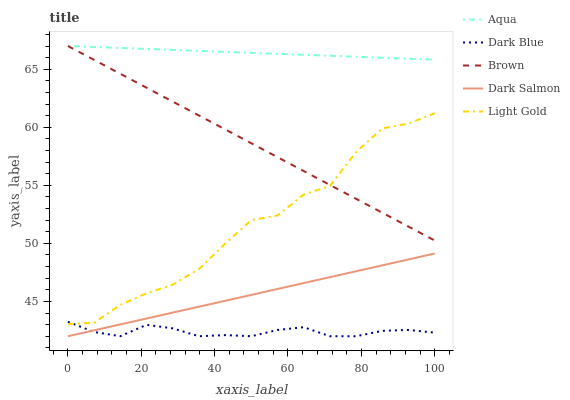Does Dark Blue have the minimum area under the curve?
Answer yes or no. Yes. Does Aqua have the maximum area under the curve?
Answer yes or no. Yes. Does Light Gold have the minimum area under the curve?
Answer yes or no. No. Does Light Gold have the maximum area under the curve?
Answer yes or no. No. Is Brown the smoothest?
Answer yes or no. Yes. Is Light Gold the roughest?
Answer yes or no. Yes. Is Aqua the smoothest?
Answer yes or no. No. Is Aqua the roughest?
Answer yes or no. No. Does Light Gold have the lowest value?
Answer yes or no. No. Does Brown have the highest value?
Answer yes or no. Yes. Does Light Gold have the highest value?
Answer yes or no. No. Is Dark Blue less than Aqua?
Answer yes or no. Yes. Is Brown greater than Dark Salmon?
Answer yes or no. Yes. Does Brown intersect Light Gold?
Answer yes or no. Yes. Is Brown less than Light Gold?
Answer yes or no. No. Is Brown greater than Light Gold?
Answer yes or no. No. Does Dark Blue intersect Aqua?
Answer yes or no. No. 